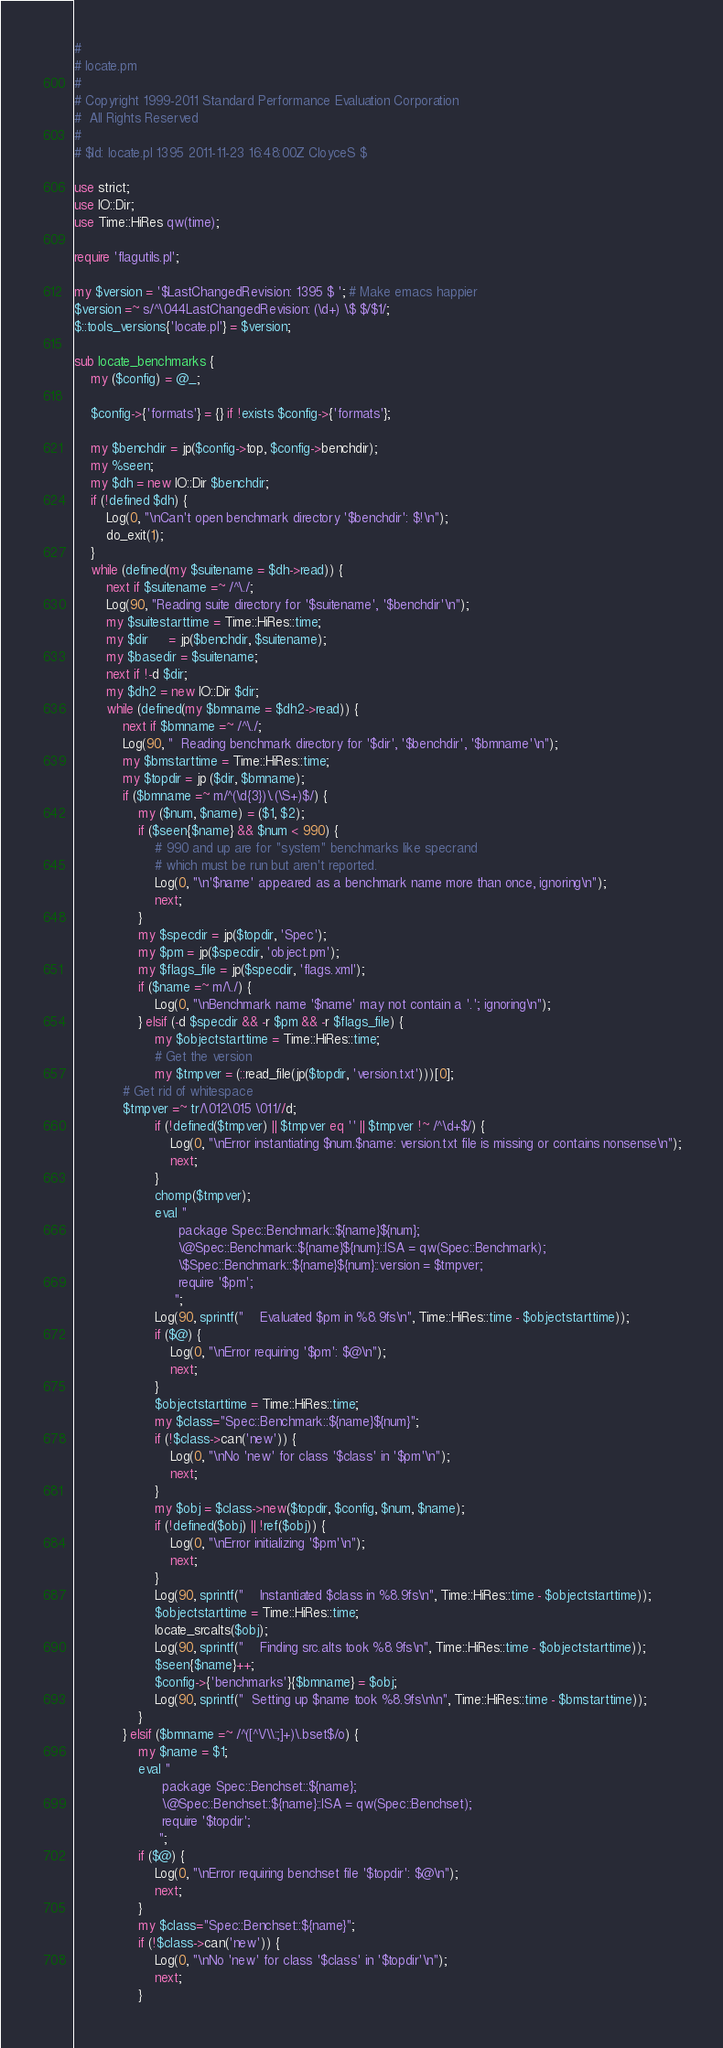<code> <loc_0><loc_0><loc_500><loc_500><_Perl_>#
# locate.pm
#
# Copyright 1999-2011 Standard Performance Evaluation Corporation
#  All Rights Reserved
#
# $Id: locate.pl 1395 2011-11-23 16:48:00Z CloyceS $

use strict;
use IO::Dir;
use Time::HiRes qw(time);

require 'flagutils.pl';

my $version = '$LastChangedRevision: 1395 $ '; # Make emacs happier
$version =~ s/^\044LastChangedRevision: (\d+) \$ $/$1/;
$::tools_versions{'locate.pl'} = $version;

sub locate_benchmarks {
    my ($config) = @_;

    $config->{'formats'} = {} if !exists $config->{'formats'};

    my $benchdir = jp($config->top, $config->benchdir);
    my %seen;
    my $dh = new IO::Dir $benchdir;
    if (!defined $dh) {
        Log(0, "\nCan't open benchmark directory '$benchdir': $!\n");
        do_exit(1);
    }
    while (defined(my $suitename = $dh->read)) {
        next if $suitename =~ /^\./;
        Log(90, "Reading suite directory for '$suitename', '$benchdir'\n");
        my $suitestarttime = Time::HiRes::time;
        my $dir     = jp($benchdir, $suitename);
        my $basedir = $suitename;
        next if !-d $dir;
        my $dh2 = new IO::Dir $dir;
        while (defined(my $bmname = $dh2->read)) { 
            next if $bmname =~ /^\./;
            Log(90, "  Reading benchmark directory for '$dir', '$benchdir', '$bmname'\n");
            my $bmstarttime = Time::HiRes::time;
            my $topdir = jp ($dir, $bmname);
            if ($bmname =~ m/^(\d{3})\.(\S+)$/) {
                my ($num, $name) = ($1, $2);
                if ($seen{$name} && $num < 990) {
                    # 990 and up are for "system" benchmarks like specrand
                    # which must be run but aren't reported.
                    Log(0, "\n'$name' appeared as a benchmark name more than once, ignoring\n");
                    next;
                }
                my $specdir = jp($topdir, 'Spec');
                my $pm = jp($specdir, 'object.pm');
                my $flags_file = jp($specdir, 'flags.xml');
                if ($name =~ m/\./) {
                    Log(0, "\nBenchmark name '$name' may not contain a '.'; ignoring\n");
                } elsif (-d $specdir && -r $pm && -r $flags_file) {
                    my $objectstarttime = Time::HiRes::time;
                    # Get the version
                    my $tmpver = (::read_file(jp($topdir, 'version.txt')))[0];
		    # Get rid of whitespace
		    $tmpver =~ tr/\012\015 \011//d;
                    if (!defined($tmpver) || $tmpver eq '' || $tmpver !~ /^\d+$/) {
                        Log(0, "\nError instantiating $num.$name: version.txt file is missing or contains nonsense\n");
                        next;
                    }
                    chomp($tmpver);
                    eval "
                          package Spec::Benchmark::${name}${num};
                          \@Spec::Benchmark::${name}${num}::ISA = qw(Spec::Benchmark);
                          \$Spec::Benchmark::${name}${num}::version = $tmpver;
                          require '$pm';
                         ";
                    Log(90, sprintf("    Evaluated $pm in %8.9fs\n", Time::HiRes::time - $objectstarttime));
                    if ($@) {
                        Log(0, "\nError requiring '$pm': $@\n");
                        next;
                    }
                    $objectstarttime = Time::HiRes::time;
                    my $class="Spec::Benchmark::${name}${num}";
                    if (!$class->can('new')) {
                        Log(0, "\nNo 'new' for class '$class' in '$pm'\n");
                        next;
                    }
                    my $obj = $class->new($topdir, $config, $num, $name);
                    if (!defined($obj) || !ref($obj)) {
                        Log(0, "\nError initializing '$pm'\n");
                        next;
                    }
                    Log(90, sprintf("    Instantiated $class in %8.9fs\n", Time::HiRes::time - $objectstarttime));
                    $objectstarttime = Time::HiRes::time;
                    locate_srcalts($obj);
                    Log(90, sprintf("    Finding src.alts took %8.9fs\n", Time::HiRes::time - $objectstarttime));
                    $seen{$name}++;
                    $config->{'benchmarks'}{$bmname} = $obj;
                    Log(90, sprintf("  Setting up $name took %8.9fs\n\n", Time::HiRes::time - $bmstarttime));
                }
            } elsif ($bmname =~ /^([^\/\\:;]+)\.bset$/o) {
                my $name = $1;
                eval "
                      package Spec::Benchset::${name};
                      \@Spec::Benchset::${name}::ISA = qw(Spec::Benchset);
                      require '$topdir';
                     ";
                if ($@) {
                    Log(0, "\nError requiring benchset file '$topdir': $@\n");
                    next;
                }
                my $class="Spec::Benchset::${name}";
                if (!$class->can('new')) {
                    Log(0, "\nNo 'new' for class '$class' in '$topdir'\n");
                    next;
                }</code> 